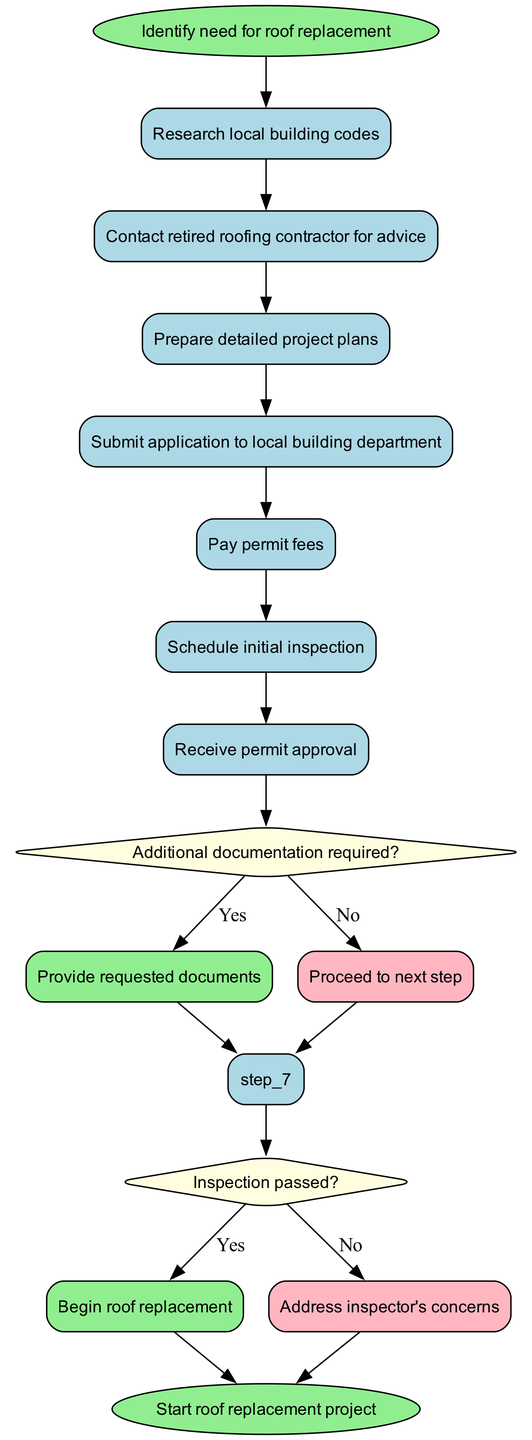What is the first step in the roof replacement process? The first step in the process, indicated by the start node, is to "Identify need for roof replacement."
Answer: Identify need for roof replacement How many steps are there before the inspection? There are 6 steps listed before reaching the initial inspection step, which includes preparing project plans and submitting the application.
Answer: 6 What do you do if additional documentation is required? If additional documentation is required, the flow indicates you should "Provide requested documents," which is connected to the 'Yes' side of the conditional step regarding documentation.
Answer: Provide requested documents What happens if the inspection does not pass? If the inspection does not pass, the next action to take is to "Address inspector's concerns," which follows the 'No' side of the conditional step regarding the inspection.
Answer: Address inspector's concerns What is the endpoint of the diagram? The endpoint of the diagram, indicated by the end node, is described as "Start roof replacement project."
Answer: Start roof replacement project How many conditional steps are there in the process? There are 2 conditional steps in the process, one regarding additional documentation and the other pertaining to the inspection results.
Answer: 2 What is the direct outcome of passing the inspection? If the inspection passes, the immediate outcome is to "Begin roof replacement." This is the action taken after confirming a positive result from the inspection.
Answer: Begin roof replacement What comes immediately after the step of paying permit fees? After paying the permit fees, the next step is to "Schedule initial inspection," as outlined in the flow of the diagram.
Answer: Schedule initial inspection What action is required following the project plan preparation? Following the preparation of detailed project plans, you are required to "Submit application to local building department." This is the next step indicated in the flow.
Answer: Submit application to local building department 